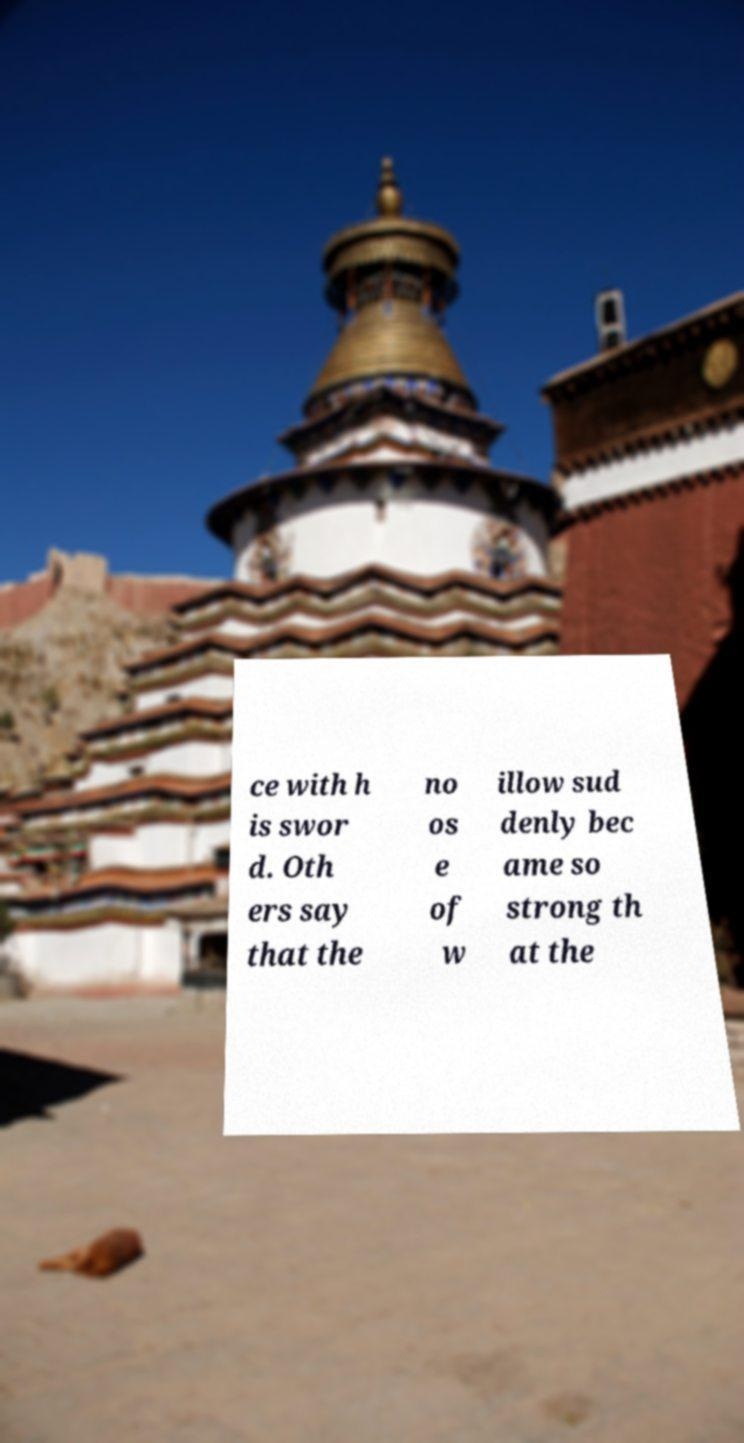There's text embedded in this image that I need extracted. Can you transcribe it verbatim? ce with h is swor d. Oth ers say that the no os e of w illow sud denly bec ame so strong th at the 